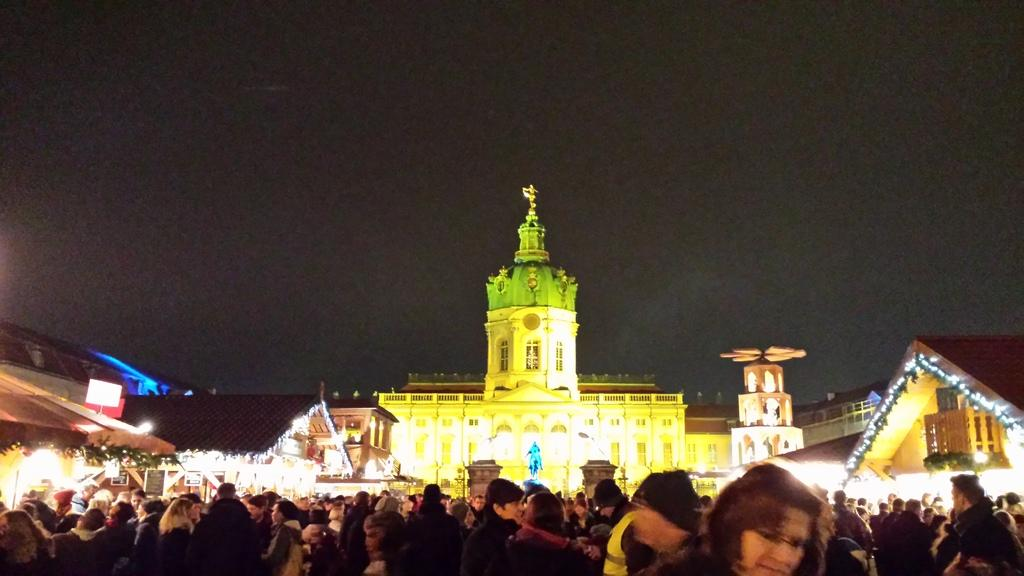Who or what is located at the bottom of the image? There are people at the bottom of the image. What structure can be seen in the background of the image? There is a building in the background of the image. What can be seen illuminating the scene in the image? There are lights visible in the image. What is visible at the top of the image? The sky is visible at the top of the image. Can you tell me how many robins are perched on the building in the image? There are no robins present in the image; it features people and a building. What type of control system is being used by the secretary in the image? There is no secretary present in the image, and therefore no control system can be observed. 